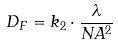<formula> <loc_0><loc_0><loc_500><loc_500>D _ { F } = k _ { 2 } \cdot \frac { \lambda } { N A ^ { 2 } }</formula> 